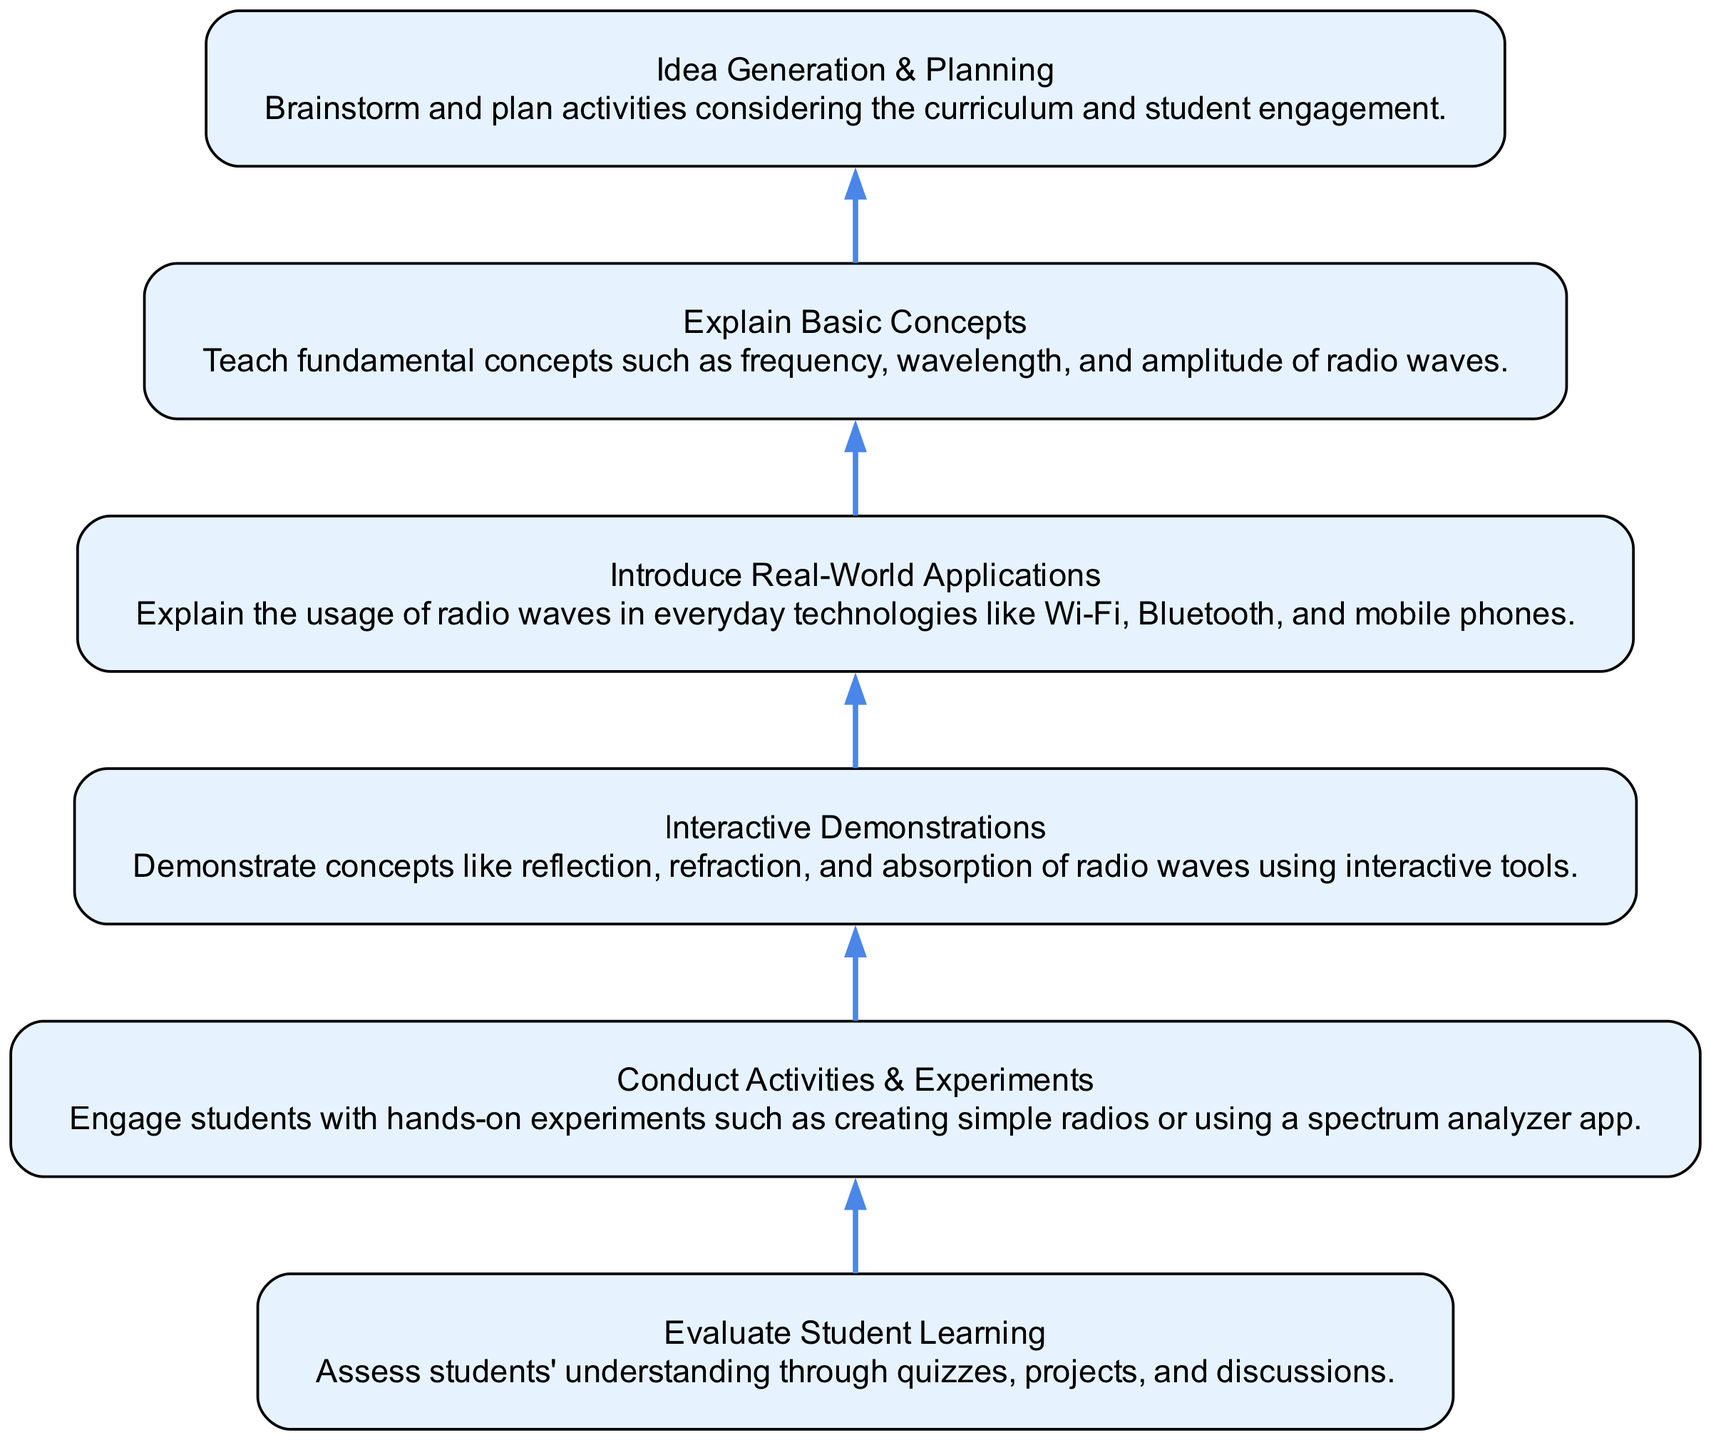What is the last step in the flow chart? The last step is "Evaluate Student Learning," which is positioned at the bottom of the flow chart indicating it is the end of the process.
Answer: Evaluate Student Learning How many nodes are present in the diagram? The diagram contains a total of six nodes that represent different stages in developing interactive activities for teaching radio waves.
Answer: Six What activity follows "Conduct Activities & Experiments"? The activity that follows is "Interactive Demonstrations," as indicated by the upward flow connecting the two nodes.
Answer: Interactive Demonstrations Which step requires "Introduce Real-World Applications" to be completed first? "Explain Basic Concepts" requires "Introduce Real-World Applications" to be completed first, as shown by the dependency relationship in the flow direction.
Answer: Explain Basic Concepts What is the relationship between "Idea Generation & Planning" and "Evaluate Student Learning"? "Idea Generation & Planning" is dependent on "Evaluate Student Learning" being conducted first, indicating that assessing learning helps in planning effective activities.
Answer: Dependency What are the essential basic concepts to be taught? The essential basic concepts include frequency, wavelength, and amplitude of radio waves, which are outlined in the corresponding node of the diagram.
Answer: Frequency, wavelength, amplitude Explain the direction of flow between "Interactive Demonstrations" and "Conduct Activities & Experiments". "Interactive Demonstrations" comes after "Conduct Activities & Experiments" in the flow chart, meaning the demonstrations build upon the hands-on experiments conducted earlier.
Answer: Upward flow Which node has the earliest place in the sequence? "Idea Generation & Planning" has the earliest place in the sequence as it is the first step in the flow chart before progressing to other activities.
Answer: Idea Generation & Planning 